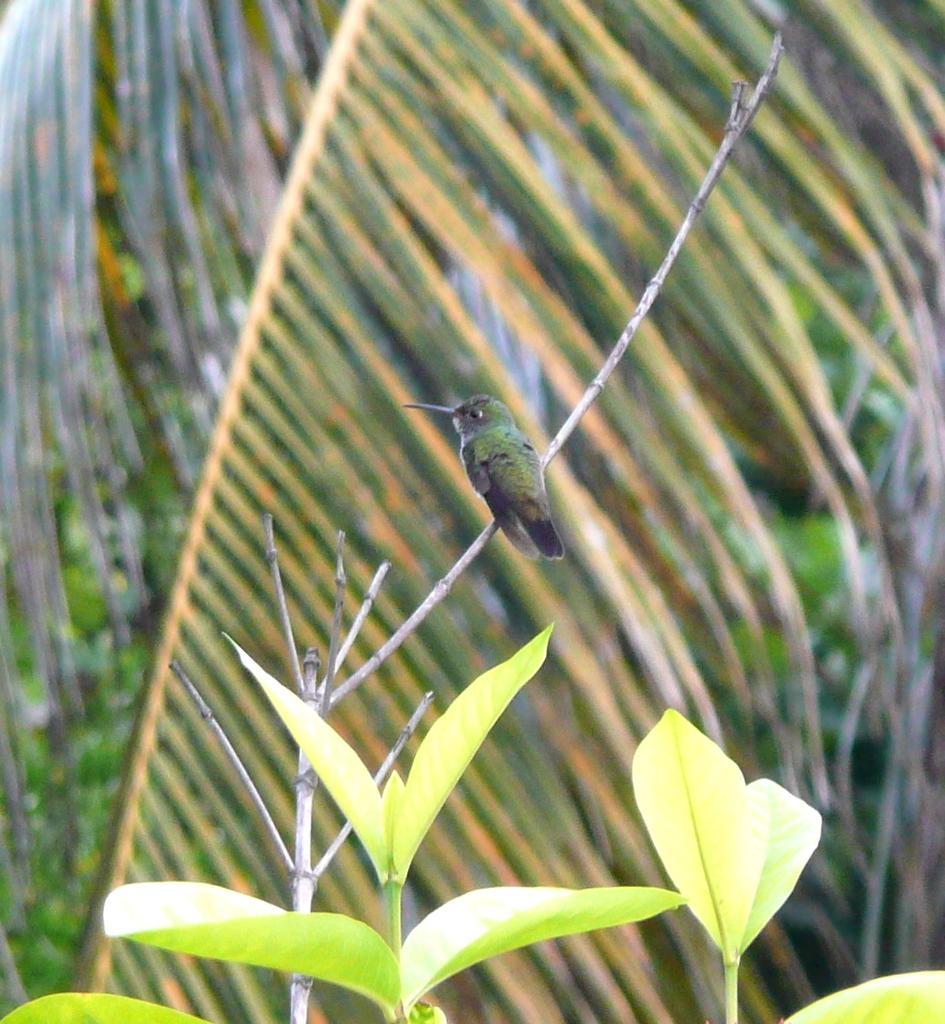Can you describe this image briefly? In this picture there is a bird on a branch and we can see leaves. In the background of the image we can see leaves. 